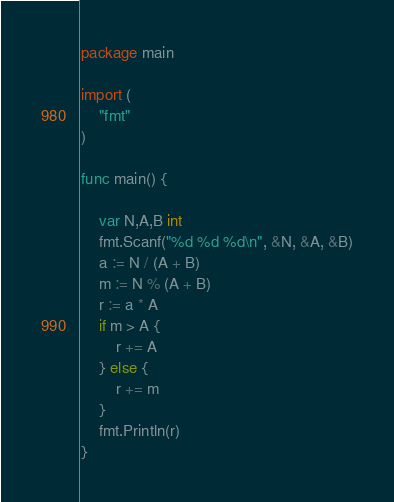<code> <loc_0><loc_0><loc_500><loc_500><_Go_>package main

import (
	"fmt"
)

func main() {

	var N,A,B int
	fmt.Scanf("%d %d %d\n", &N, &A, &B)
	a := N / (A + B)
	m := N % (A + B)
	r := a * A
	if m > A {
		r += A
	} else {
		r += m
	}
	fmt.Println(r)
}
</code> 